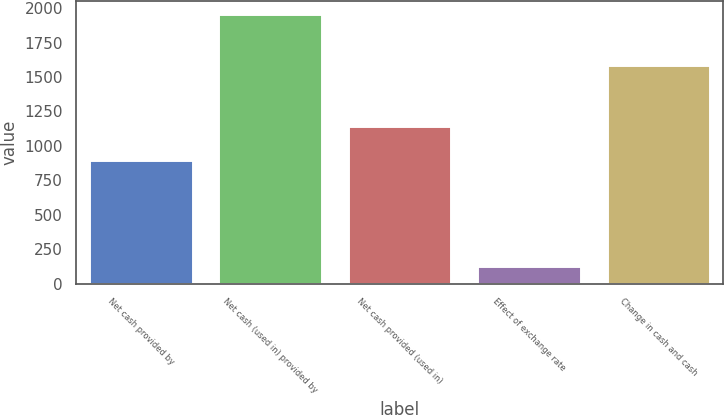Convert chart. <chart><loc_0><loc_0><loc_500><loc_500><bar_chart><fcel>Net cash provided by<fcel>Net cash (used in) provided by<fcel>Net cash provided (used in)<fcel>Effect of exchange rate<fcel>Change in cash and cash<nl><fcel>899<fcel>1956<fcel>1141<fcel>130<fcel>1584<nl></chart> 